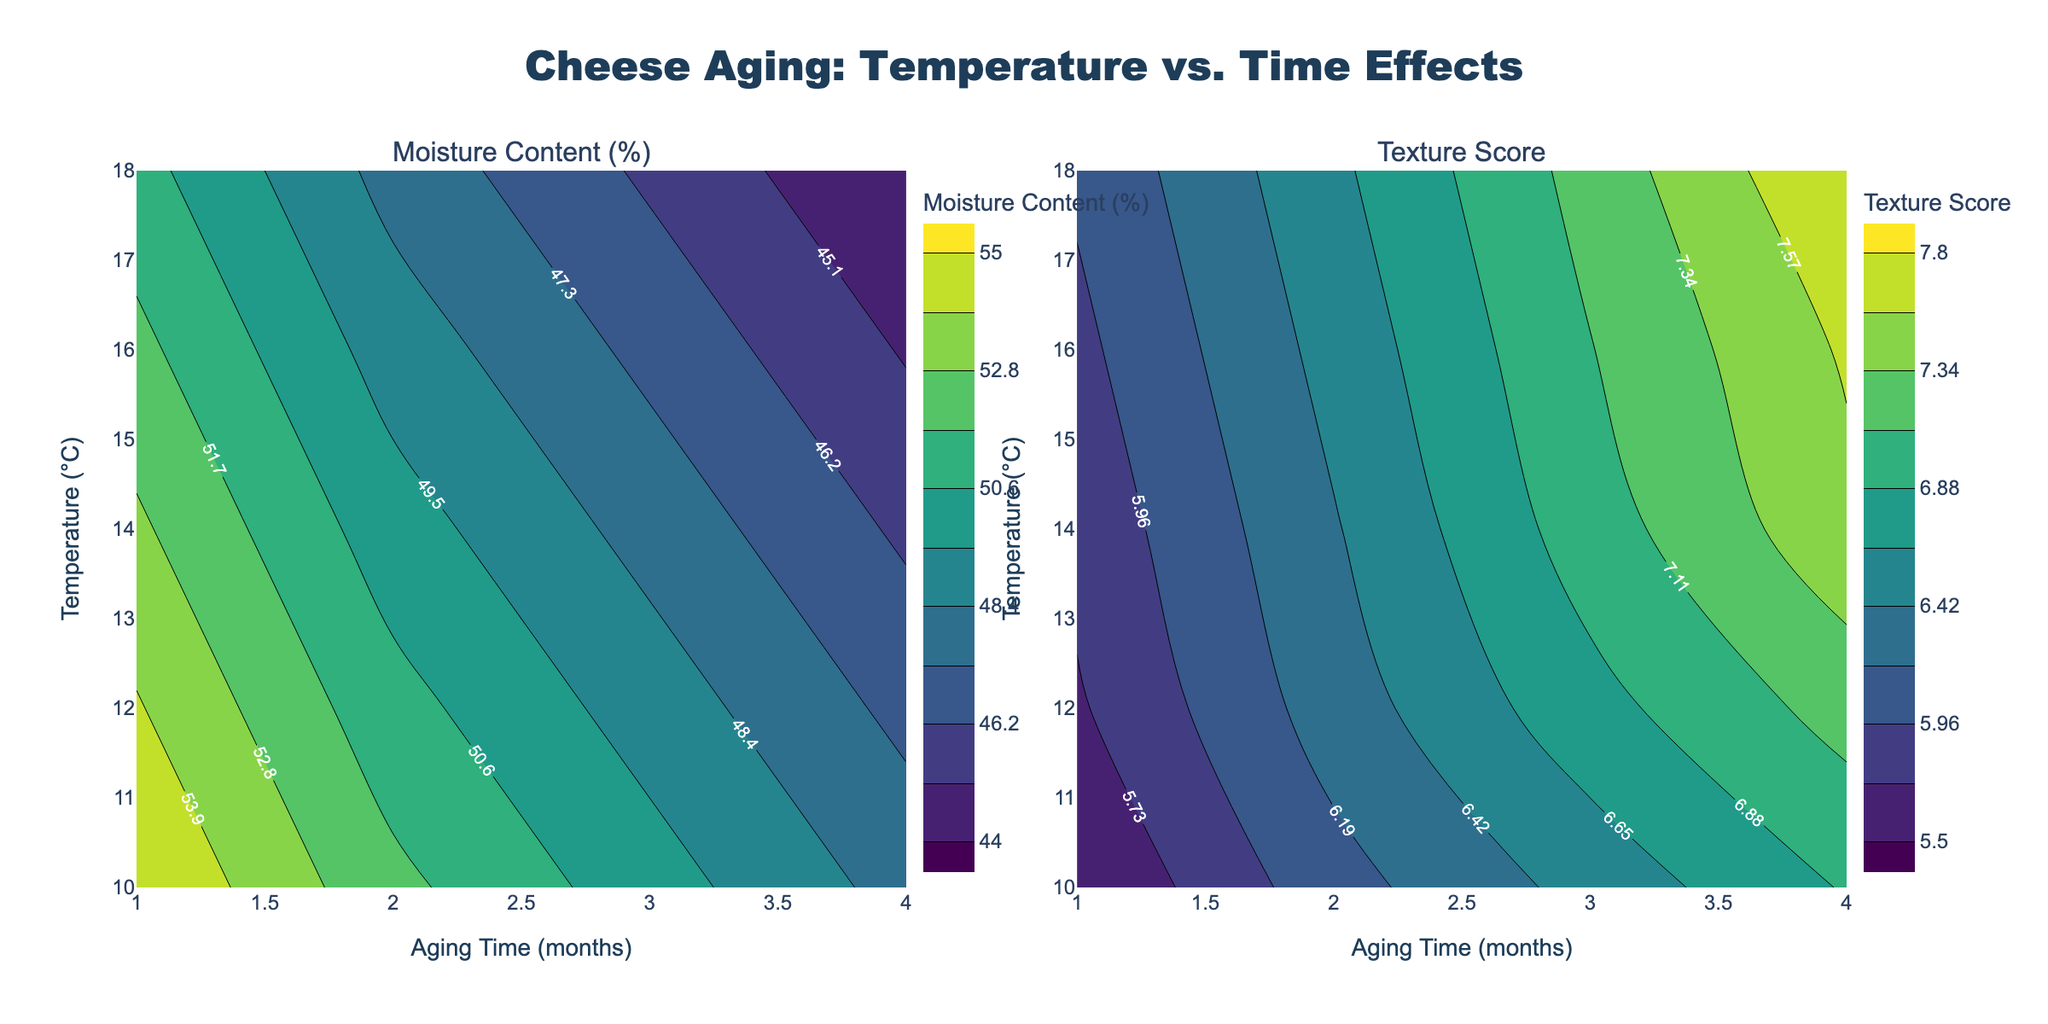What is the title of the figure? The title is located at the top center of the figure and it reads "Cheese Aging: Temperature vs. Time Effects".
Answer: Cheese Aging: Temperature vs. Time Effects What are the labels on the x-axis and y-axis of the plots? The x-axis is labeled "Aging Time (months)" and the y-axis is labeled "Temperature (°C)" on both subplots.
Answer: Aging Time (months), Temperature (°C) What color scale is used for the contour plots? The color scale for the contour plots is "Viridis", which is typically a gradient from purple to green to yellow.
Answer: Viridis Is there a difference in the shape of the contour lines between the Moisture Content and Texture Score plots? Yes, by observing the contour shapes, the Moisture Content (%), which is generally smoother and more spread out, differs from the Texture Score, which appears to have more distinct and tighter contour lines.
Answer: Yes How does the moisture content change with increasing aging time at a constant temperature of 16°C? At 16°C, as the aging time increases from 1 month to 4 months, the moisture content decreases from approximately 52% to 45%.
Answer: It decreases How does the texture score change with increasing temperature at a constant aging time of 3 months? At an aging time of 3 months, as the temperature increases from 10°C to 18°C, the texture score increases from approximately 6.5 to 7.2.
Answer: It increases What is the general trend of the moisture content when both temperature and aging time increase? When both temperature and aging time increase, the moisture content generally decreases. This can be inferred from the downward gradient of the contour lines in the Moisture Content plot.
Answer: It decreases Which aging time results in the highest texture score at any temperature? By examining the Texture Score plot, the highest texture scores are observed at an aging time of 4 months across various temperatures.
Answer: 4 months What are the approximate moisture content values at 12°C for aging times of 1 month and 4 months? Referring to the moisture content plot at 12°C, the moisture content values are approximately 54% at 1 month and 47% at 4 months.
Answer: 54%, 47% What is the flavor score at 10°C and 3 months? (Use deduction based on given patterns) Given that flavor score trends similarly to texture score, interpolating from neighboring values (5.8 at 2 months, 6.2 at 4 months, 6.5 at 3 months but not shown), it would be consistent to estimate a flavor score around 5.8-6.0 at 10°C and 3 months.
Answer: Around 5.8-6.0 